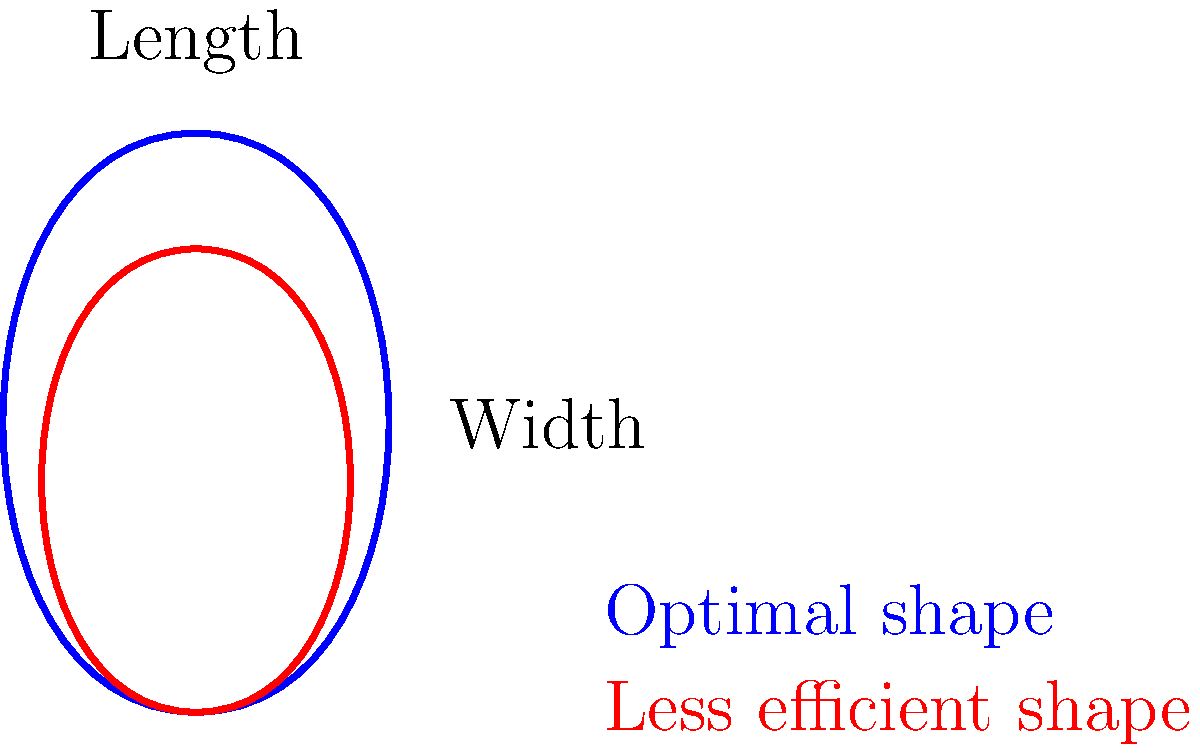In optimizing the shape of a tennis racket head for maximum power and control, which aspect of the design should be prioritized according to the diagram? To answer this question, let's analyze the diagram step-by-step:

1. The diagram shows two racket head shapes: a blue outline (optimal shape) and a red outline (less efficient shape).

2. Both shapes are elliptical, but the blue shape is more elongated compared to the red shape.

3. The vertical axis is labeled "Length," and the horizontal axis is labeled "Width."

4. Comparing the two shapes:
   a. The blue shape has a greater length-to-width ratio.
   b. The red shape is more circular, with a smaller length-to-width ratio.

5. In tennis racket design:
   a. A longer head generally provides more power due to increased leverage.
   b. A wider head typically offers a larger sweet spot, potentially improving control.

6. The optimal shape (blue) prioritizes length over width, suggesting that:
   a. Increased length is more crucial for optimizing power and control.
   b. The trade-off between power and control is better balanced with an elongated shape.

7. This design choice likely results in:
   a. Increased swing speed due to reduced air resistance.
   b. A larger sweet spot along the vertical axis of the racket.
   c. Improved power transfer from the player's swing to the ball.

Therefore, based on the diagram, the aspect of design that should be prioritized is the length of the racket head, creating a more elongated shape for optimal power and control.
Answer: Length of the racket head 